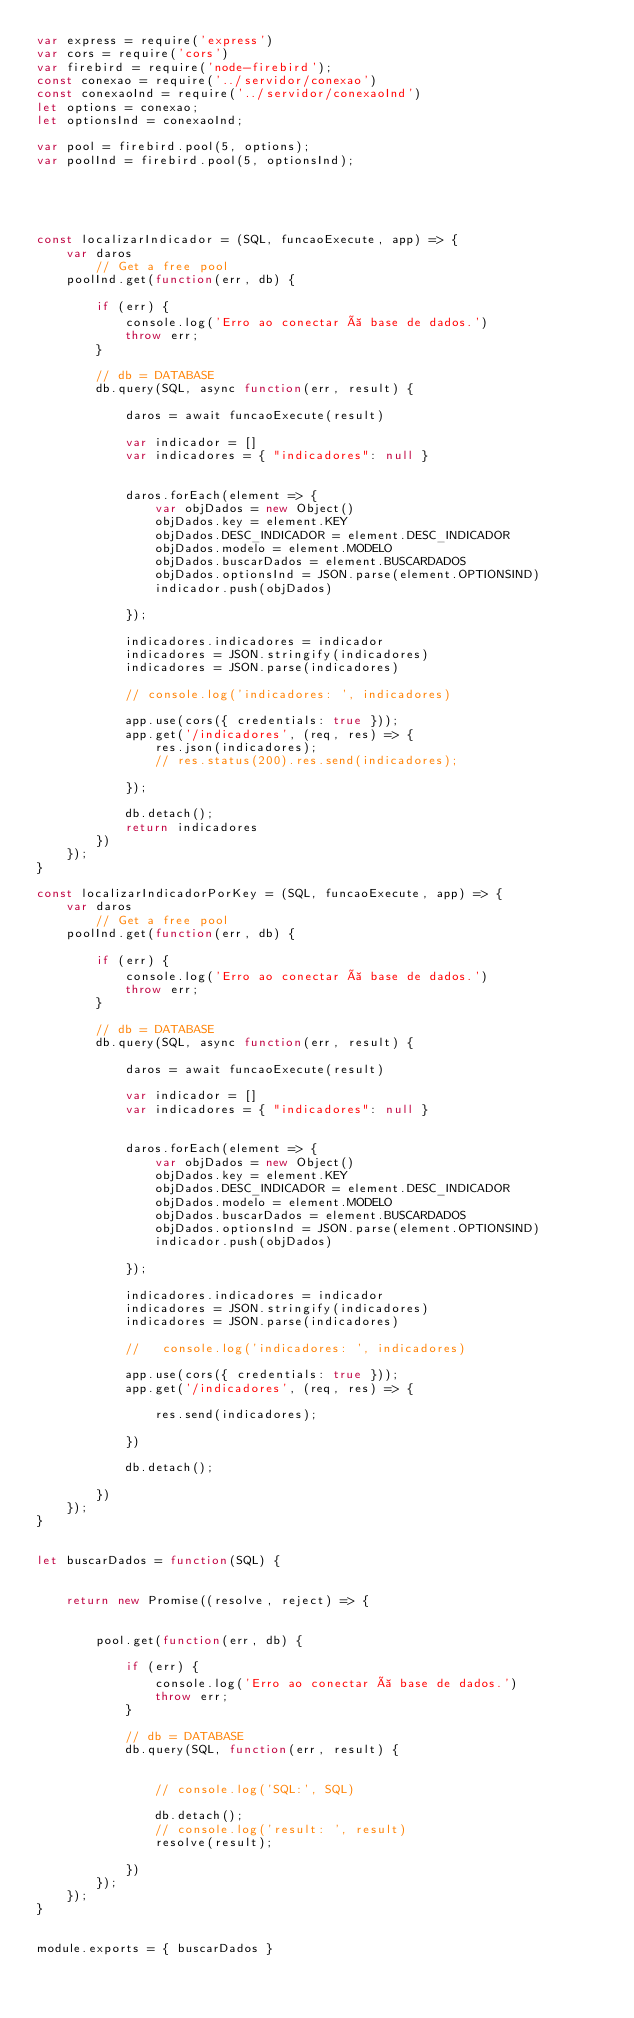Convert code to text. <code><loc_0><loc_0><loc_500><loc_500><_JavaScript_>var express = require('express')
var cors = require('cors')
var firebird = require('node-firebird');
const conexao = require('../servidor/conexao')
const conexaoInd = require('../servidor/conexaoInd')
let options = conexao;
let optionsInd = conexaoInd;

var pool = firebird.pool(5, options);
var poolInd = firebird.pool(5, optionsInd);





const localizarIndicador = (SQL, funcaoExecute, app) => {
    var daros
        // Get a free pool
    poolInd.get(function(err, db) {

        if (err) {
            console.log('Erro ao conectar à base de dados.')
            throw err;
        }

        // db = DATABASE
        db.query(SQL, async function(err, result) {

            daros = await funcaoExecute(result)

            var indicador = []
            var indicadores = { "indicadores": null }


            daros.forEach(element => {
                var objDados = new Object()
                objDados.key = element.KEY
                objDados.DESC_INDICADOR = element.DESC_INDICADOR
                objDados.modelo = element.MODELO
                objDados.buscarDados = element.BUSCARDADOS
                objDados.optionsInd = JSON.parse(element.OPTIONSIND)
                indicador.push(objDados)

            });

            indicadores.indicadores = indicador
            indicadores = JSON.stringify(indicadores)
            indicadores = JSON.parse(indicadores)

            // console.log('indicadores: ', indicadores)

            app.use(cors({ credentials: true }));
            app.get('/indicadores', (req, res) => {
                res.json(indicadores);
                // res.status(200).res.send(indicadores);

            });

            db.detach();
            return indicadores
        })
    });
}

const localizarIndicadorPorKey = (SQL, funcaoExecute, app) => {
    var daros
        // Get a free pool
    poolInd.get(function(err, db) {

        if (err) {
            console.log('Erro ao conectar à base de dados.')
            throw err;
        }

        // db = DATABASE
        db.query(SQL, async function(err, result) {

            daros = await funcaoExecute(result)

            var indicador = []
            var indicadores = { "indicadores": null }


            daros.forEach(element => {
                var objDados = new Object()
                objDados.key = element.KEY
                objDados.DESC_INDICADOR = element.DESC_INDICADOR
                objDados.modelo = element.MODELO
                objDados.buscarDados = element.BUSCARDADOS
                objDados.optionsInd = JSON.parse(element.OPTIONSIND)
                indicador.push(objDados)

            });

            indicadores.indicadores = indicador
            indicadores = JSON.stringify(indicadores)
            indicadores = JSON.parse(indicadores)

            //   console.log('indicadores: ', indicadores)

            app.use(cors({ credentials: true }));
            app.get('/indicadores', (req, res) => {

                res.send(indicadores);

            })

            db.detach();

        })
    });
}


let buscarDados = function(SQL) {


    return new Promise((resolve, reject) => {


        pool.get(function(err, db) {

            if (err) {
                console.log('Erro ao conectar à base de dados.')
                throw err;
            }

            // db = DATABASE
            db.query(SQL, function(err, result) {


                // console.log('SQL:', SQL)

                db.detach();
                // console.log('result: ', result)
                resolve(result);

            })
        });
    });
}


module.exports = { buscarDados }</code> 